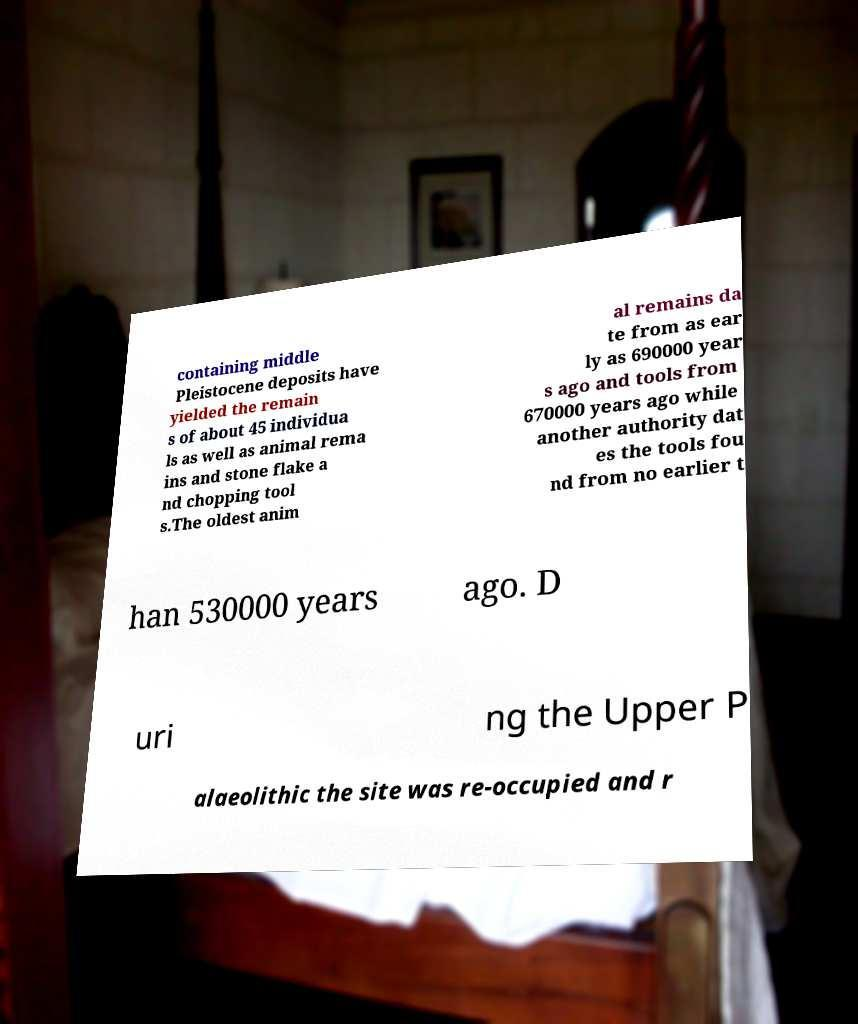There's text embedded in this image that I need extracted. Can you transcribe it verbatim? containing middle Pleistocene deposits have yielded the remain s of about 45 individua ls as well as animal rema ins and stone flake a nd chopping tool s.The oldest anim al remains da te from as ear ly as 690000 year s ago and tools from 670000 years ago while another authority dat es the tools fou nd from no earlier t han 530000 years ago. D uri ng the Upper P alaeolithic the site was re-occupied and r 